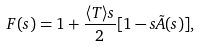Convert formula to latex. <formula><loc_0><loc_0><loc_500><loc_500>F ( s ) = 1 + \frac { \langle T \rangle s } { 2 } [ 1 - s \tilde { A } ( s ) ] ,</formula> 